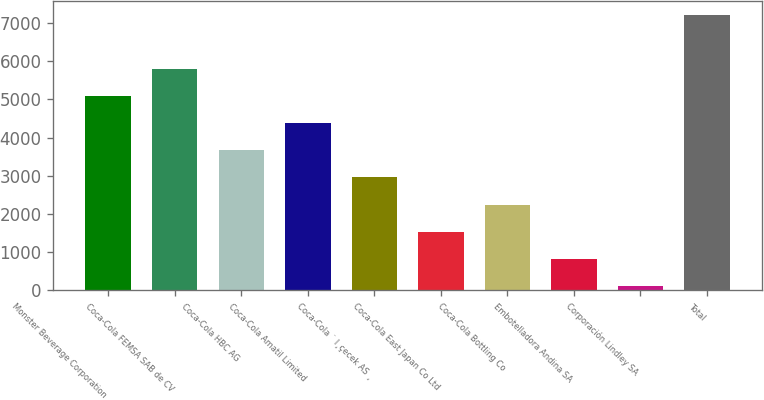Convert chart to OTSL. <chart><loc_0><loc_0><loc_500><loc_500><bar_chart><fcel>Monster Beverage Corporation<fcel>Coca-Cola FEMSA SAB de CV<fcel>Coca-Cola HBC AG<fcel>Coca-Cola Amatil Limited<fcel>Coca-Cola ˙ I¸çecek AS ¸<fcel>Coca-Cola East Japan Co Ltd<fcel>Coca-Cola Bottling Co<fcel>Embotelladora Andina SA<fcel>Corporación Lindley SA<fcel>Total<nl><fcel>5089.9<fcel>5801.6<fcel>3666.5<fcel>4378.2<fcel>2954.8<fcel>1531.4<fcel>2243.1<fcel>819.7<fcel>108<fcel>7225<nl></chart> 